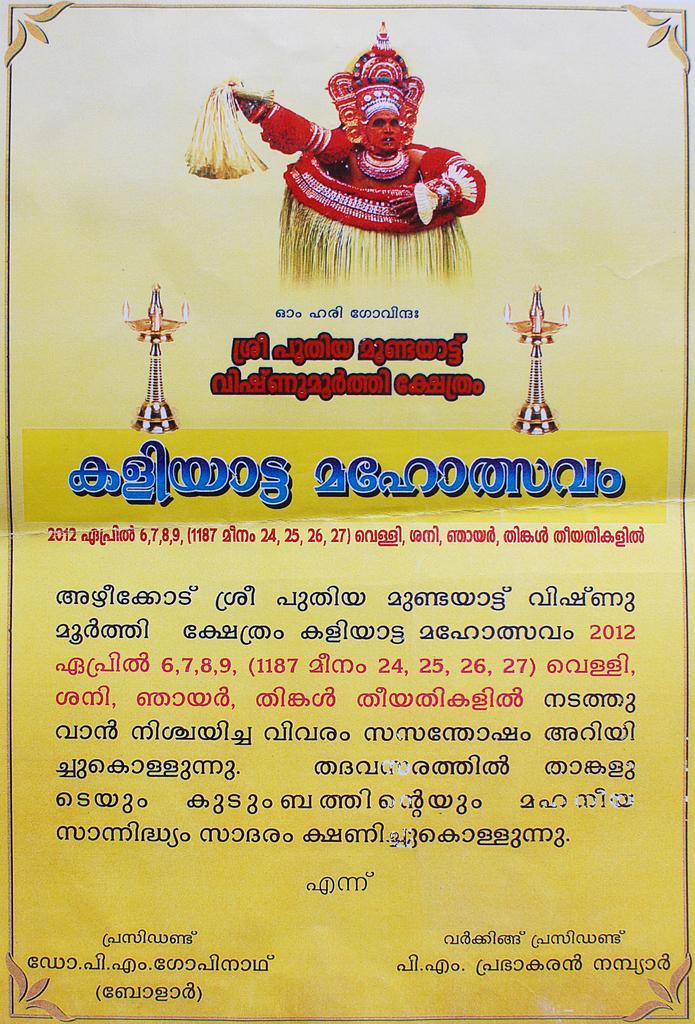In one or two sentences, can you explain what this image depicts? In this image we can see a poster on which there is some text in different language and there is a man who is wearing traditional dress of Kerala. 